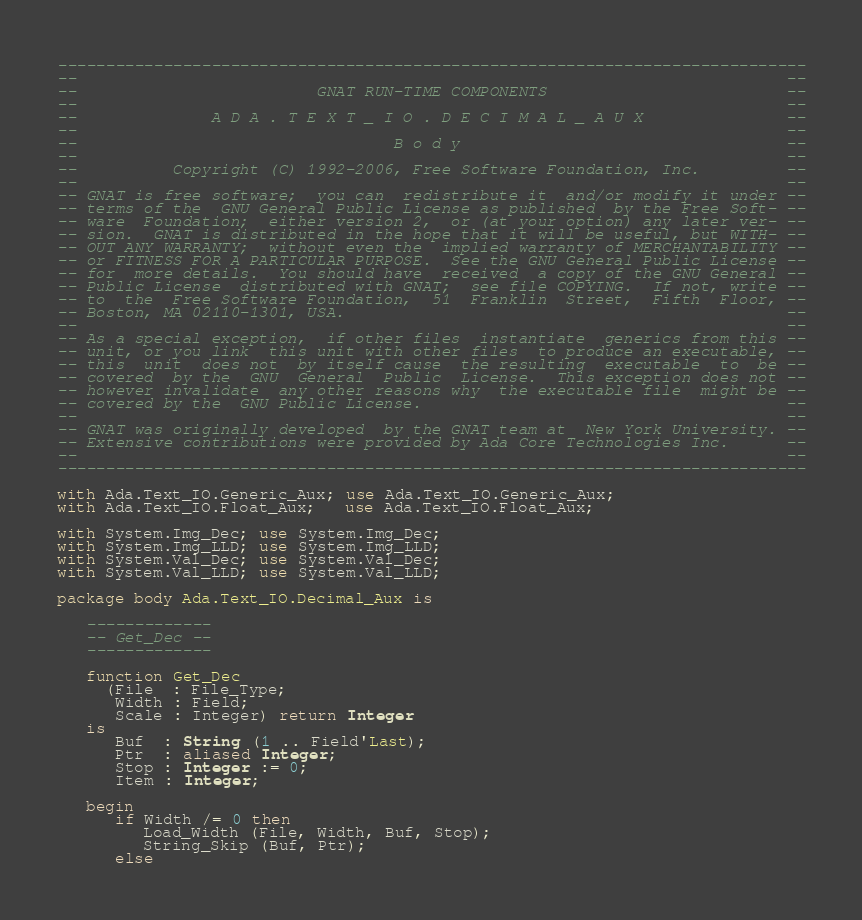Convert code to text. <code><loc_0><loc_0><loc_500><loc_500><_Ada_>------------------------------------------------------------------------------
--                                                                          --
--                         GNAT RUN-TIME COMPONENTS                         --
--                                                                          --
--              A D A . T E X T _ I O . D E C I M A L _ A U X               --
--                                                                          --
--                                 B o d y                                  --
--                                                                          --
--          Copyright (C) 1992-2006, Free Software Foundation, Inc.         --
--                                                                          --
-- GNAT is free software;  you can  redistribute it  and/or modify it under --
-- terms of the  GNU General Public License as published  by the Free Soft- --
-- ware  Foundation;  either version 2,  or (at your option) any later ver- --
-- sion.  GNAT is distributed in the hope that it will be useful, but WITH- --
-- OUT ANY WARRANTY;  without even the  implied warranty of MERCHANTABILITY --
-- or FITNESS FOR A PARTICULAR PURPOSE.  See the GNU General Public License --
-- for  more details.  You should have  received  a copy of the GNU General --
-- Public License  distributed with GNAT;  see file COPYING.  If not, write --
-- to  the  Free Software Foundation,  51  Franklin  Street,  Fifth  Floor, --
-- Boston, MA 02110-1301, USA.                                              --
--                                                                          --
-- As a special exception,  if other files  instantiate  generics from this --
-- unit, or you link  this unit with other files  to produce an executable, --
-- this  unit  does not  by itself cause  the resulting  executable  to  be --
-- covered  by the  GNU  General  Public  License.  This exception does not --
-- however invalidate  any other reasons why  the executable file  might be --
-- covered by the  GNU Public License.                                      --
--                                                                          --
-- GNAT was originally developed  by the GNAT team at  New York University. --
-- Extensive contributions were provided by Ada Core Technologies Inc.      --
--                                                                          --
------------------------------------------------------------------------------

with Ada.Text_IO.Generic_Aux; use Ada.Text_IO.Generic_Aux;
with Ada.Text_IO.Float_Aux;   use Ada.Text_IO.Float_Aux;

with System.Img_Dec; use System.Img_Dec;
with System.Img_LLD; use System.Img_LLD;
with System.Val_Dec; use System.Val_Dec;
with System.Val_LLD; use System.Val_LLD;

package body Ada.Text_IO.Decimal_Aux is

   -------------
   -- Get_Dec --
   -------------

   function Get_Dec
     (File  : File_Type;
      Width : Field;
      Scale : Integer) return Integer
   is
      Buf  : String (1 .. Field'Last);
      Ptr  : aliased Integer;
      Stop : Integer := 0;
      Item : Integer;

   begin
      if Width /= 0 then
         Load_Width (File, Width, Buf, Stop);
         String_Skip (Buf, Ptr);
      else</code> 